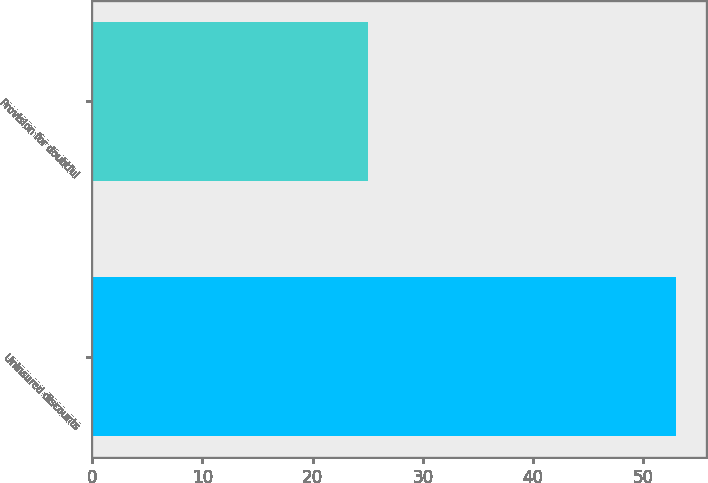Convert chart to OTSL. <chart><loc_0><loc_0><loc_500><loc_500><bar_chart><fcel>Uninsured discounts<fcel>Provision for doubtful<nl><fcel>53<fcel>25<nl></chart> 